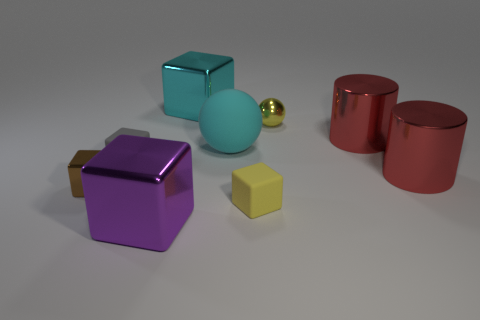Subtract all tiny brown blocks. How many blocks are left? 4 Subtract all purple blocks. How many blocks are left? 4 Add 1 yellow metallic things. How many objects exist? 10 Subtract all balls. How many objects are left? 7 Subtract all gray cubes. Subtract all purple cylinders. How many cubes are left? 4 Add 7 yellow cubes. How many yellow cubes are left? 8 Add 2 big red rubber blocks. How many big red rubber blocks exist? 2 Subtract 0 blue balls. How many objects are left? 9 Subtract all tiny brown shiny objects. Subtract all big purple blocks. How many objects are left? 7 